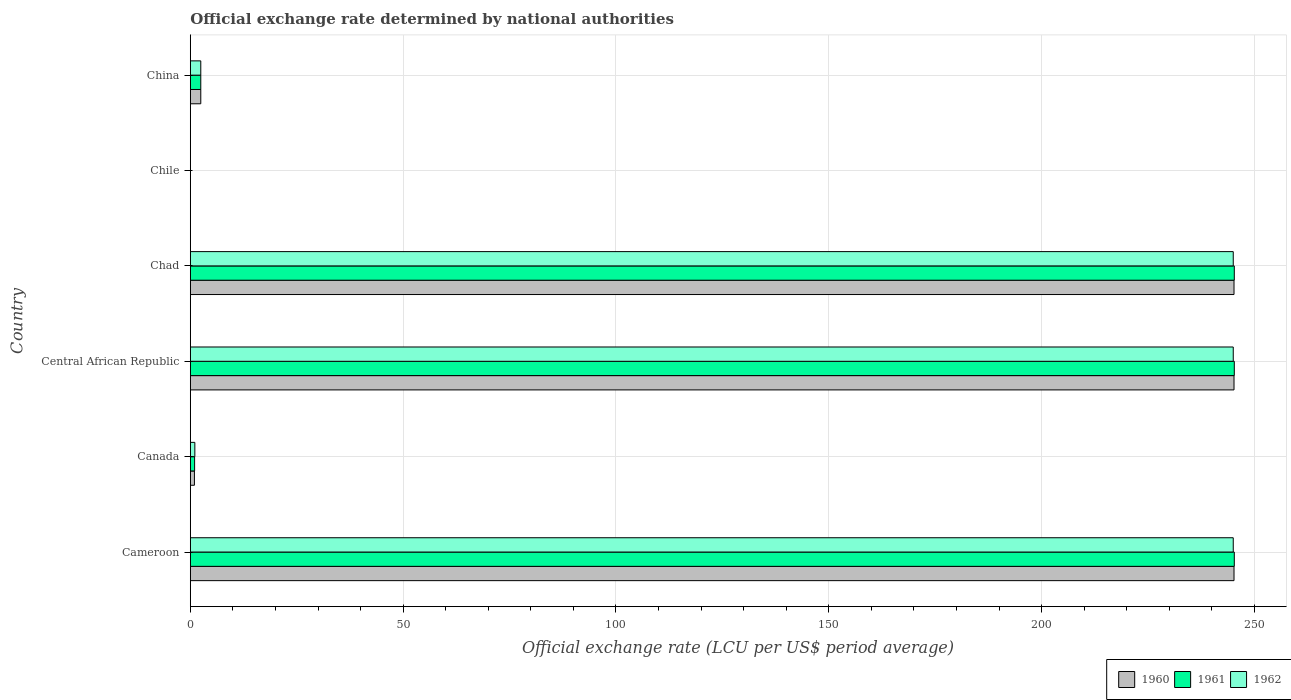How many different coloured bars are there?
Your answer should be compact. 3. How many groups of bars are there?
Your response must be concise. 6. How many bars are there on the 2nd tick from the top?
Offer a terse response. 3. What is the label of the 1st group of bars from the top?
Provide a succinct answer. China. In how many cases, is the number of bars for a given country not equal to the number of legend labels?
Ensure brevity in your answer.  0. What is the official exchange rate in 1960 in Central African Republic?
Offer a terse response. 245.2. Across all countries, what is the maximum official exchange rate in 1961?
Give a very brief answer. 245.26. Across all countries, what is the minimum official exchange rate in 1962?
Make the answer very short. 0. In which country was the official exchange rate in 1961 maximum?
Keep it short and to the point. Cameroon. In which country was the official exchange rate in 1962 minimum?
Your response must be concise. Chile. What is the total official exchange rate in 1961 in the graph?
Your response must be concise. 739.26. What is the difference between the official exchange rate in 1962 in Central African Republic and that in Chad?
Keep it short and to the point. -9.947598300641403e-13. What is the difference between the official exchange rate in 1960 in China and the official exchange rate in 1961 in Chile?
Make the answer very short. 2.46. What is the average official exchange rate in 1961 per country?
Provide a succinct answer. 123.21. What is the difference between the official exchange rate in 1962 and official exchange rate in 1961 in Chad?
Your response must be concise. -0.25. What is the ratio of the official exchange rate in 1962 in Canada to that in China?
Offer a very short reply. 0.43. Is the official exchange rate in 1961 in Cameroon less than that in Chad?
Keep it short and to the point. No. Is the difference between the official exchange rate in 1962 in Central African Republic and Chad greater than the difference between the official exchange rate in 1961 in Central African Republic and Chad?
Offer a terse response. No. What is the difference between the highest and the second highest official exchange rate in 1960?
Your answer should be very brief. 0. What is the difference between the highest and the lowest official exchange rate in 1962?
Your answer should be very brief. 245.01. What is the difference between two consecutive major ticks on the X-axis?
Offer a very short reply. 50. Does the graph contain any zero values?
Offer a terse response. No. Does the graph contain grids?
Offer a very short reply. Yes. Where does the legend appear in the graph?
Your answer should be very brief. Bottom right. How many legend labels are there?
Provide a short and direct response. 3. What is the title of the graph?
Your answer should be very brief. Official exchange rate determined by national authorities. Does "1993" appear as one of the legend labels in the graph?
Your response must be concise. No. What is the label or title of the X-axis?
Provide a succinct answer. Official exchange rate (LCU per US$ period average). What is the Official exchange rate (LCU per US$ period average) of 1960 in Cameroon?
Give a very brief answer. 245.2. What is the Official exchange rate (LCU per US$ period average) in 1961 in Cameroon?
Keep it short and to the point. 245.26. What is the Official exchange rate (LCU per US$ period average) of 1962 in Cameroon?
Make the answer very short. 245.01. What is the Official exchange rate (LCU per US$ period average) of 1960 in Canada?
Make the answer very short. 0.97. What is the Official exchange rate (LCU per US$ period average) of 1961 in Canada?
Ensure brevity in your answer.  1.01. What is the Official exchange rate (LCU per US$ period average) of 1962 in Canada?
Your response must be concise. 1.07. What is the Official exchange rate (LCU per US$ period average) in 1960 in Central African Republic?
Your answer should be compact. 245.2. What is the Official exchange rate (LCU per US$ period average) in 1961 in Central African Republic?
Make the answer very short. 245.26. What is the Official exchange rate (LCU per US$ period average) of 1962 in Central African Republic?
Ensure brevity in your answer.  245.01. What is the Official exchange rate (LCU per US$ period average) in 1960 in Chad?
Provide a short and direct response. 245.2. What is the Official exchange rate (LCU per US$ period average) in 1961 in Chad?
Ensure brevity in your answer.  245.26. What is the Official exchange rate (LCU per US$ period average) in 1962 in Chad?
Provide a short and direct response. 245.01. What is the Official exchange rate (LCU per US$ period average) in 1960 in Chile?
Give a very brief answer. 0. What is the Official exchange rate (LCU per US$ period average) in 1961 in Chile?
Make the answer very short. 0. What is the Official exchange rate (LCU per US$ period average) of 1962 in Chile?
Your response must be concise. 0. What is the Official exchange rate (LCU per US$ period average) of 1960 in China?
Keep it short and to the point. 2.46. What is the Official exchange rate (LCU per US$ period average) in 1961 in China?
Provide a succinct answer. 2.46. What is the Official exchange rate (LCU per US$ period average) of 1962 in China?
Provide a short and direct response. 2.46. Across all countries, what is the maximum Official exchange rate (LCU per US$ period average) in 1960?
Keep it short and to the point. 245.2. Across all countries, what is the maximum Official exchange rate (LCU per US$ period average) of 1961?
Your answer should be compact. 245.26. Across all countries, what is the maximum Official exchange rate (LCU per US$ period average) of 1962?
Your response must be concise. 245.01. Across all countries, what is the minimum Official exchange rate (LCU per US$ period average) of 1960?
Offer a terse response. 0. Across all countries, what is the minimum Official exchange rate (LCU per US$ period average) of 1961?
Give a very brief answer. 0. Across all countries, what is the minimum Official exchange rate (LCU per US$ period average) of 1962?
Give a very brief answer. 0. What is the total Official exchange rate (LCU per US$ period average) of 1960 in the graph?
Provide a succinct answer. 739.02. What is the total Official exchange rate (LCU per US$ period average) in 1961 in the graph?
Your answer should be compact. 739.26. What is the total Official exchange rate (LCU per US$ period average) of 1962 in the graph?
Your response must be concise. 738.57. What is the difference between the Official exchange rate (LCU per US$ period average) in 1960 in Cameroon and that in Canada?
Make the answer very short. 244.23. What is the difference between the Official exchange rate (LCU per US$ period average) of 1961 in Cameroon and that in Canada?
Provide a short and direct response. 244.25. What is the difference between the Official exchange rate (LCU per US$ period average) of 1962 in Cameroon and that in Canada?
Give a very brief answer. 243.95. What is the difference between the Official exchange rate (LCU per US$ period average) of 1961 in Cameroon and that in Central African Republic?
Offer a terse response. 0. What is the difference between the Official exchange rate (LCU per US$ period average) of 1962 in Cameroon and that in Central African Republic?
Your answer should be compact. 0. What is the difference between the Official exchange rate (LCU per US$ period average) in 1961 in Cameroon and that in Chad?
Provide a short and direct response. 0. What is the difference between the Official exchange rate (LCU per US$ period average) in 1960 in Cameroon and that in Chile?
Your answer should be compact. 245.19. What is the difference between the Official exchange rate (LCU per US$ period average) in 1961 in Cameroon and that in Chile?
Keep it short and to the point. 245.26. What is the difference between the Official exchange rate (LCU per US$ period average) in 1962 in Cameroon and that in Chile?
Provide a succinct answer. 245.01. What is the difference between the Official exchange rate (LCU per US$ period average) in 1960 in Cameroon and that in China?
Offer a terse response. 242.73. What is the difference between the Official exchange rate (LCU per US$ period average) in 1961 in Cameroon and that in China?
Provide a short and direct response. 242.8. What is the difference between the Official exchange rate (LCU per US$ period average) in 1962 in Cameroon and that in China?
Provide a succinct answer. 242.55. What is the difference between the Official exchange rate (LCU per US$ period average) of 1960 in Canada and that in Central African Republic?
Provide a succinct answer. -244.23. What is the difference between the Official exchange rate (LCU per US$ period average) of 1961 in Canada and that in Central African Republic?
Provide a short and direct response. -244.25. What is the difference between the Official exchange rate (LCU per US$ period average) in 1962 in Canada and that in Central African Republic?
Make the answer very short. -243.95. What is the difference between the Official exchange rate (LCU per US$ period average) in 1960 in Canada and that in Chad?
Offer a terse response. -244.23. What is the difference between the Official exchange rate (LCU per US$ period average) of 1961 in Canada and that in Chad?
Give a very brief answer. -244.25. What is the difference between the Official exchange rate (LCU per US$ period average) of 1962 in Canada and that in Chad?
Provide a short and direct response. -243.95. What is the difference between the Official exchange rate (LCU per US$ period average) of 1960 in Canada and that in Chile?
Your answer should be very brief. 0.97. What is the difference between the Official exchange rate (LCU per US$ period average) of 1962 in Canada and that in Chile?
Offer a terse response. 1.07. What is the difference between the Official exchange rate (LCU per US$ period average) in 1960 in Canada and that in China?
Offer a very short reply. -1.49. What is the difference between the Official exchange rate (LCU per US$ period average) in 1961 in Canada and that in China?
Offer a terse response. -1.45. What is the difference between the Official exchange rate (LCU per US$ period average) of 1962 in Canada and that in China?
Give a very brief answer. -1.39. What is the difference between the Official exchange rate (LCU per US$ period average) of 1960 in Central African Republic and that in Chile?
Provide a short and direct response. 245.19. What is the difference between the Official exchange rate (LCU per US$ period average) in 1961 in Central African Republic and that in Chile?
Your answer should be very brief. 245.26. What is the difference between the Official exchange rate (LCU per US$ period average) of 1962 in Central African Republic and that in Chile?
Your answer should be very brief. 245.01. What is the difference between the Official exchange rate (LCU per US$ period average) of 1960 in Central African Republic and that in China?
Make the answer very short. 242.73. What is the difference between the Official exchange rate (LCU per US$ period average) in 1961 in Central African Republic and that in China?
Make the answer very short. 242.8. What is the difference between the Official exchange rate (LCU per US$ period average) in 1962 in Central African Republic and that in China?
Provide a short and direct response. 242.55. What is the difference between the Official exchange rate (LCU per US$ period average) of 1960 in Chad and that in Chile?
Your response must be concise. 245.19. What is the difference between the Official exchange rate (LCU per US$ period average) in 1961 in Chad and that in Chile?
Provide a succinct answer. 245.26. What is the difference between the Official exchange rate (LCU per US$ period average) in 1962 in Chad and that in Chile?
Offer a very short reply. 245.01. What is the difference between the Official exchange rate (LCU per US$ period average) in 1960 in Chad and that in China?
Provide a succinct answer. 242.73. What is the difference between the Official exchange rate (LCU per US$ period average) in 1961 in Chad and that in China?
Your answer should be compact. 242.8. What is the difference between the Official exchange rate (LCU per US$ period average) of 1962 in Chad and that in China?
Give a very brief answer. 242.55. What is the difference between the Official exchange rate (LCU per US$ period average) in 1960 in Chile and that in China?
Give a very brief answer. -2.46. What is the difference between the Official exchange rate (LCU per US$ period average) in 1961 in Chile and that in China?
Provide a short and direct response. -2.46. What is the difference between the Official exchange rate (LCU per US$ period average) of 1962 in Chile and that in China?
Offer a terse response. -2.46. What is the difference between the Official exchange rate (LCU per US$ period average) of 1960 in Cameroon and the Official exchange rate (LCU per US$ period average) of 1961 in Canada?
Provide a succinct answer. 244.18. What is the difference between the Official exchange rate (LCU per US$ period average) of 1960 in Cameroon and the Official exchange rate (LCU per US$ period average) of 1962 in Canada?
Keep it short and to the point. 244.13. What is the difference between the Official exchange rate (LCU per US$ period average) in 1961 in Cameroon and the Official exchange rate (LCU per US$ period average) in 1962 in Canada?
Your answer should be very brief. 244.19. What is the difference between the Official exchange rate (LCU per US$ period average) in 1960 in Cameroon and the Official exchange rate (LCU per US$ period average) in 1961 in Central African Republic?
Your answer should be very brief. -0.07. What is the difference between the Official exchange rate (LCU per US$ period average) in 1960 in Cameroon and the Official exchange rate (LCU per US$ period average) in 1962 in Central African Republic?
Provide a succinct answer. 0.18. What is the difference between the Official exchange rate (LCU per US$ period average) in 1961 in Cameroon and the Official exchange rate (LCU per US$ period average) in 1962 in Central African Republic?
Your answer should be compact. 0.25. What is the difference between the Official exchange rate (LCU per US$ period average) in 1960 in Cameroon and the Official exchange rate (LCU per US$ period average) in 1961 in Chad?
Ensure brevity in your answer.  -0.07. What is the difference between the Official exchange rate (LCU per US$ period average) of 1960 in Cameroon and the Official exchange rate (LCU per US$ period average) of 1962 in Chad?
Keep it short and to the point. 0.18. What is the difference between the Official exchange rate (LCU per US$ period average) in 1961 in Cameroon and the Official exchange rate (LCU per US$ period average) in 1962 in Chad?
Offer a terse response. 0.25. What is the difference between the Official exchange rate (LCU per US$ period average) in 1960 in Cameroon and the Official exchange rate (LCU per US$ period average) in 1961 in Chile?
Give a very brief answer. 245.19. What is the difference between the Official exchange rate (LCU per US$ period average) in 1960 in Cameroon and the Official exchange rate (LCU per US$ period average) in 1962 in Chile?
Provide a succinct answer. 245.19. What is the difference between the Official exchange rate (LCU per US$ period average) of 1961 in Cameroon and the Official exchange rate (LCU per US$ period average) of 1962 in Chile?
Offer a terse response. 245.26. What is the difference between the Official exchange rate (LCU per US$ period average) in 1960 in Cameroon and the Official exchange rate (LCU per US$ period average) in 1961 in China?
Keep it short and to the point. 242.73. What is the difference between the Official exchange rate (LCU per US$ period average) in 1960 in Cameroon and the Official exchange rate (LCU per US$ period average) in 1962 in China?
Ensure brevity in your answer.  242.73. What is the difference between the Official exchange rate (LCU per US$ period average) in 1961 in Cameroon and the Official exchange rate (LCU per US$ period average) in 1962 in China?
Offer a very short reply. 242.8. What is the difference between the Official exchange rate (LCU per US$ period average) of 1960 in Canada and the Official exchange rate (LCU per US$ period average) of 1961 in Central African Republic?
Your response must be concise. -244.29. What is the difference between the Official exchange rate (LCU per US$ period average) of 1960 in Canada and the Official exchange rate (LCU per US$ period average) of 1962 in Central African Republic?
Keep it short and to the point. -244.04. What is the difference between the Official exchange rate (LCU per US$ period average) in 1961 in Canada and the Official exchange rate (LCU per US$ period average) in 1962 in Central African Republic?
Keep it short and to the point. -244. What is the difference between the Official exchange rate (LCU per US$ period average) in 1960 in Canada and the Official exchange rate (LCU per US$ period average) in 1961 in Chad?
Offer a terse response. -244.29. What is the difference between the Official exchange rate (LCU per US$ period average) of 1960 in Canada and the Official exchange rate (LCU per US$ period average) of 1962 in Chad?
Provide a short and direct response. -244.04. What is the difference between the Official exchange rate (LCU per US$ period average) in 1961 in Canada and the Official exchange rate (LCU per US$ period average) in 1962 in Chad?
Ensure brevity in your answer.  -244. What is the difference between the Official exchange rate (LCU per US$ period average) of 1960 in Canada and the Official exchange rate (LCU per US$ period average) of 1961 in Chile?
Keep it short and to the point. 0.97. What is the difference between the Official exchange rate (LCU per US$ period average) of 1960 in Canada and the Official exchange rate (LCU per US$ period average) of 1962 in Chile?
Ensure brevity in your answer.  0.97. What is the difference between the Official exchange rate (LCU per US$ period average) of 1961 in Canada and the Official exchange rate (LCU per US$ period average) of 1962 in Chile?
Your answer should be very brief. 1.01. What is the difference between the Official exchange rate (LCU per US$ period average) in 1960 in Canada and the Official exchange rate (LCU per US$ period average) in 1961 in China?
Ensure brevity in your answer.  -1.49. What is the difference between the Official exchange rate (LCU per US$ period average) in 1960 in Canada and the Official exchange rate (LCU per US$ period average) in 1962 in China?
Provide a short and direct response. -1.49. What is the difference between the Official exchange rate (LCU per US$ period average) of 1961 in Canada and the Official exchange rate (LCU per US$ period average) of 1962 in China?
Keep it short and to the point. -1.45. What is the difference between the Official exchange rate (LCU per US$ period average) of 1960 in Central African Republic and the Official exchange rate (LCU per US$ period average) of 1961 in Chad?
Offer a terse response. -0.07. What is the difference between the Official exchange rate (LCU per US$ period average) in 1960 in Central African Republic and the Official exchange rate (LCU per US$ period average) in 1962 in Chad?
Give a very brief answer. 0.18. What is the difference between the Official exchange rate (LCU per US$ period average) in 1961 in Central African Republic and the Official exchange rate (LCU per US$ period average) in 1962 in Chad?
Make the answer very short. 0.25. What is the difference between the Official exchange rate (LCU per US$ period average) of 1960 in Central African Republic and the Official exchange rate (LCU per US$ period average) of 1961 in Chile?
Ensure brevity in your answer.  245.19. What is the difference between the Official exchange rate (LCU per US$ period average) of 1960 in Central African Republic and the Official exchange rate (LCU per US$ period average) of 1962 in Chile?
Your response must be concise. 245.19. What is the difference between the Official exchange rate (LCU per US$ period average) of 1961 in Central African Republic and the Official exchange rate (LCU per US$ period average) of 1962 in Chile?
Ensure brevity in your answer.  245.26. What is the difference between the Official exchange rate (LCU per US$ period average) in 1960 in Central African Republic and the Official exchange rate (LCU per US$ period average) in 1961 in China?
Keep it short and to the point. 242.73. What is the difference between the Official exchange rate (LCU per US$ period average) in 1960 in Central African Republic and the Official exchange rate (LCU per US$ period average) in 1962 in China?
Make the answer very short. 242.73. What is the difference between the Official exchange rate (LCU per US$ period average) of 1961 in Central African Republic and the Official exchange rate (LCU per US$ period average) of 1962 in China?
Offer a terse response. 242.8. What is the difference between the Official exchange rate (LCU per US$ period average) of 1960 in Chad and the Official exchange rate (LCU per US$ period average) of 1961 in Chile?
Offer a terse response. 245.19. What is the difference between the Official exchange rate (LCU per US$ period average) in 1960 in Chad and the Official exchange rate (LCU per US$ period average) in 1962 in Chile?
Provide a succinct answer. 245.19. What is the difference between the Official exchange rate (LCU per US$ period average) in 1961 in Chad and the Official exchange rate (LCU per US$ period average) in 1962 in Chile?
Provide a short and direct response. 245.26. What is the difference between the Official exchange rate (LCU per US$ period average) in 1960 in Chad and the Official exchange rate (LCU per US$ period average) in 1961 in China?
Offer a terse response. 242.73. What is the difference between the Official exchange rate (LCU per US$ period average) in 1960 in Chad and the Official exchange rate (LCU per US$ period average) in 1962 in China?
Make the answer very short. 242.73. What is the difference between the Official exchange rate (LCU per US$ period average) of 1961 in Chad and the Official exchange rate (LCU per US$ period average) of 1962 in China?
Offer a terse response. 242.8. What is the difference between the Official exchange rate (LCU per US$ period average) of 1960 in Chile and the Official exchange rate (LCU per US$ period average) of 1961 in China?
Make the answer very short. -2.46. What is the difference between the Official exchange rate (LCU per US$ period average) of 1960 in Chile and the Official exchange rate (LCU per US$ period average) of 1962 in China?
Give a very brief answer. -2.46. What is the difference between the Official exchange rate (LCU per US$ period average) of 1961 in Chile and the Official exchange rate (LCU per US$ period average) of 1962 in China?
Your answer should be very brief. -2.46. What is the average Official exchange rate (LCU per US$ period average) of 1960 per country?
Offer a very short reply. 123.17. What is the average Official exchange rate (LCU per US$ period average) in 1961 per country?
Offer a very short reply. 123.21. What is the average Official exchange rate (LCU per US$ period average) in 1962 per country?
Provide a succinct answer. 123.1. What is the difference between the Official exchange rate (LCU per US$ period average) in 1960 and Official exchange rate (LCU per US$ period average) in 1961 in Cameroon?
Offer a very short reply. -0.07. What is the difference between the Official exchange rate (LCU per US$ period average) in 1960 and Official exchange rate (LCU per US$ period average) in 1962 in Cameroon?
Give a very brief answer. 0.18. What is the difference between the Official exchange rate (LCU per US$ period average) in 1961 and Official exchange rate (LCU per US$ period average) in 1962 in Cameroon?
Your answer should be compact. 0.25. What is the difference between the Official exchange rate (LCU per US$ period average) of 1960 and Official exchange rate (LCU per US$ period average) of 1961 in Canada?
Offer a terse response. -0.04. What is the difference between the Official exchange rate (LCU per US$ period average) in 1960 and Official exchange rate (LCU per US$ period average) in 1962 in Canada?
Offer a very short reply. -0.1. What is the difference between the Official exchange rate (LCU per US$ period average) in 1961 and Official exchange rate (LCU per US$ period average) in 1962 in Canada?
Keep it short and to the point. -0.06. What is the difference between the Official exchange rate (LCU per US$ period average) of 1960 and Official exchange rate (LCU per US$ period average) of 1961 in Central African Republic?
Your answer should be very brief. -0.07. What is the difference between the Official exchange rate (LCU per US$ period average) of 1960 and Official exchange rate (LCU per US$ period average) of 1962 in Central African Republic?
Keep it short and to the point. 0.18. What is the difference between the Official exchange rate (LCU per US$ period average) of 1961 and Official exchange rate (LCU per US$ period average) of 1962 in Central African Republic?
Your answer should be very brief. 0.25. What is the difference between the Official exchange rate (LCU per US$ period average) in 1960 and Official exchange rate (LCU per US$ period average) in 1961 in Chad?
Provide a succinct answer. -0.07. What is the difference between the Official exchange rate (LCU per US$ period average) in 1960 and Official exchange rate (LCU per US$ period average) in 1962 in Chad?
Provide a short and direct response. 0.18. What is the difference between the Official exchange rate (LCU per US$ period average) in 1961 and Official exchange rate (LCU per US$ period average) in 1962 in Chad?
Provide a short and direct response. 0.25. What is the difference between the Official exchange rate (LCU per US$ period average) of 1960 and Official exchange rate (LCU per US$ period average) of 1961 in Chile?
Make the answer very short. -0. What is the difference between the Official exchange rate (LCU per US$ period average) of 1960 and Official exchange rate (LCU per US$ period average) of 1961 in China?
Make the answer very short. 0. What is the difference between the Official exchange rate (LCU per US$ period average) in 1961 and Official exchange rate (LCU per US$ period average) in 1962 in China?
Provide a short and direct response. 0. What is the ratio of the Official exchange rate (LCU per US$ period average) in 1960 in Cameroon to that in Canada?
Your response must be concise. 252.83. What is the ratio of the Official exchange rate (LCU per US$ period average) of 1961 in Cameroon to that in Canada?
Your answer should be very brief. 242.1. What is the ratio of the Official exchange rate (LCU per US$ period average) of 1962 in Cameroon to that in Canada?
Offer a terse response. 229.25. What is the ratio of the Official exchange rate (LCU per US$ period average) of 1960 in Cameroon to that in Central African Republic?
Give a very brief answer. 1. What is the ratio of the Official exchange rate (LCU per US$ period average) of 1961 in Cameroon to that in Central African Republic?
Provide a succinct answer. 1. What is the ratio of the Official exchange rate (LCU per US$ period average) of 1960 in Cameroon to that in Chad?
Ensure brevity in your answer.  1. What is the ratio of the Official exchange rate (LCU per US$ period average) in 1962 in Cameroon to that in Chad?
Provide a succinct answer. 1. What is the ratio of the Official exchange rate (LCU per US$ period average) in 1960 in Cameroon to that in Chile?
Your answer should be very brief. 2.34e+05. What is the ratio of the Official exchange rate (LCU per US$ period average) of 1961 in Cameroon to that in Chile?
Offer a terse response. 2.34e+05. What is the ratio of the Official exchange rate (LCU per US$ period average) of 1962 in Cameroon to that in Chile?
Give a very brief answer. 2.32e+05. What is the ratio of the Official exchange rate (LCU per US$ period average) in 1960 in Cameroon to that in China?
Provide a succinct answer. 99.6. What is the ratio of the Official exchange rate (LCU per US$ period average) of 1961 in Cameroon to that in China?
Ensure brevity in your answer.  99.63. What is the ratio of the Official exchange rate (LCU per US$ period average) in 1962 in Cameroon to that in China?
Ensure brevity in your answer.  99.53. What is the ratio of the Official exchange rate (LCU per US$ period average) of 1960 in Canada to that in Central African Republic?
Keep it short and to the point. 0. What is the ratio of the Official exchange rate (LCU per US$ period average) in 1961 in Canada to that in Central African Republic?
Your answer should be compact. 0. What is the ratio of the Official exchange rate (LCU per US$ period average) of 1962 in Canada to that in Central African Republic?
Give a very brief answer. 0. What is the ratio of the Official exchange rate (LCU per US$ period average) of 1960 in Canada to that in Chad?
Offer a very short reply. 0. What is the ratio of the Official exchange rate (LCU per US$ period average) in 1961 in Canada to that in Chad?
Make the answer very short. 0. What is the ratio of the Official exchange rate (LCU per US$ period average) in 1962 in Canada to that in Chad?
Give a very brief answer. 0. What is the ratio of the Official exchange rate (LCU per US$ period average) of 1960 in Canada to that in Chile?
Offer a very short reply. 924.51. What is the ratio of the Official exchange rate (LCU per US$ period average) of 1961 in Canada to that in Chile?
Offer a terse response. 964.7. What is the ratio of the Official exchange rate (LCU per US$ period average) of 1962 in Canada to that in Chile?
Ensure brevity in your answer.  1010.52. What is the ratio of the Official exchange rate (LCU per US$ period average) in 1960 in Canada to that in China?
Your response must be concise. 0.39. What is the ratio of the Official exchange rate (LCU per US$ period average) in 1961 in Canada to that in China?
Give a very brief answer. 0.41. What is the ratio of the Official exchange rate (LCU per US$ period average) in 1962 in Canada to that in China?
Your response must be concise. 0.43. What is the ratio of the Official exchange rate (LCU per US$ period average) in 1961 in Central African Republic to that in Chad?
Your answer should be compact. 1. What is the ratio of the Official exchange rate (LCU per US$ period average) of 1960 in Central African Republic to that in Chile?
Offer a very short reply. 2.34e+05. What is the ratio of the Official exchange rate (LCU per US$ period average) in 1961 in Central African Republic to that in Chile?
Your answer should be very brief. 2.34e+05. What is the ratio of the Official exchange rate (LCU per US$ period average) of 1962 in Central African Republic to that in Chile?
Your answer should be very brief. 2.32e+05. What is the ratio of the Official exchange rate (LCU per US$ period average) in 1960 in Central African Republic to that in China?
Your answer should be very brief. 99.6. What is the ratio of the Official exchange rate (LCU per US$ period average) in 1961 in Central African Republic to that in China?
Provide a short and direct response. 99.63. What is the ratio of the Official exchange rate (LCU per US$ period average) in 1962 in Central African Republic to that in China?
Provide a short and direct response. 99.53. What is the ratio of the Official exchange rate (LCU per US$ period average) of 1960 in Chad to that in Chile?
Provide a short and direct response. 2.34e+05. What is the ratio of the Official exchange rate (LCU per US$ period average) in 1961 in Chad to that in Chile?
Provide a short and direct response. 2.34e+05. What is the ratio of the Official exchange rate (LCU per US$ period average) of 1962 in Chad to that in Chile?
Ensure brevity in your answer.  2.32e+05. What is the ratio of the Official exchange rate (LCU per US$ period average) of 1960 in Chad to that in China?
Ensure brevity in your answer.  99.6. What is the ratio of the Official exchange rate (LCU per US$ period average) of 1961 in Chad to that in China?
Keep it short and to the point. 99.63. What is the ratio of the Official exchange rate (LCU per US$ period average) of 1962 in Chad to that in China?
Ensure brevity in your answer.  99.53. What is the ratio of the Official exchange rate (LCU per US$ period average) of 1960 in Chile to that in China?
Your answer should be compact. 0. What is the ratio of the Official exchange rate (LCU per US$ period average) of 1961 in Chile to that in China?
Make the answer very short. 0. What is the difference between the highest and the second highest Official exchange rate (LCU per US$ period average) in 1961?
Give a very brief answer. 0. What is the difference between the highest and the lowest Official exchange rate (LCU per US$ period average) in 1960?
Your answer should be very brief. 245.19. What is the difference between the highest and the lowest Official exchange rate (LCU per US$ period average) in 1961?
Provide a succinct answer. 245.26. What is the difference between the highest and the lowest Official exchange rate (LCU per US$ period average) in 1962?
Offer a terse response. 245.01. 